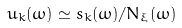Convert formula to latex. <formula><loc_0><loc_0><loc_500><loc_500>u _ { k } ( \omega ) \simeq s _ { k } ( \omega ) / N _ { \xi } ( \omega )</formula> 